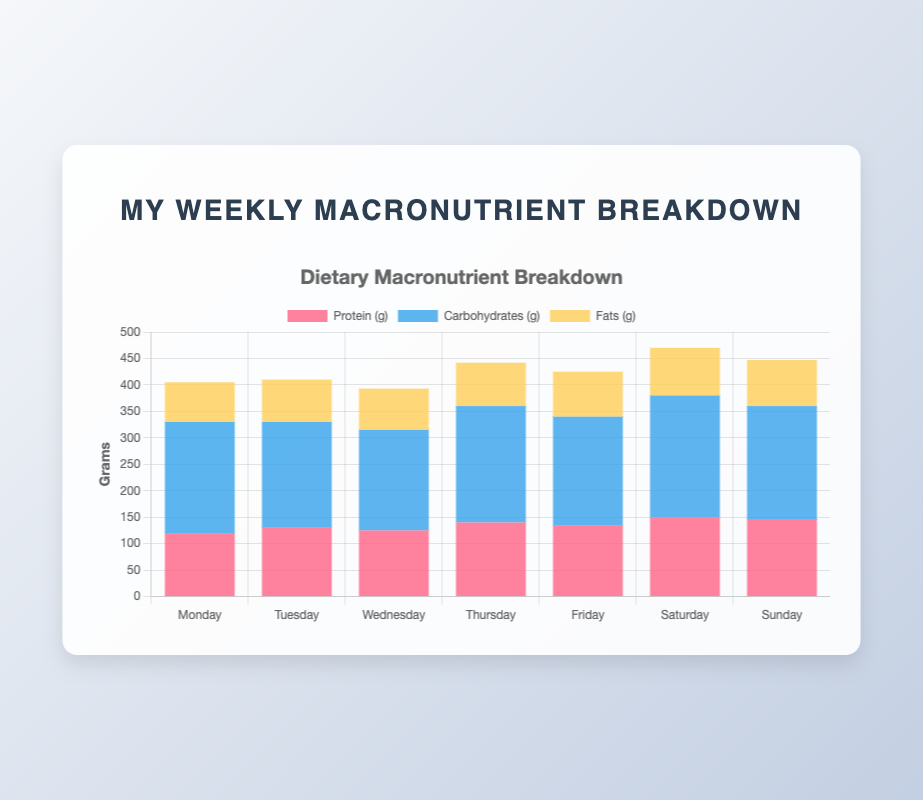What is the total amount of protein consumed over the week? Sum the protein intake for each day: 120 + 130 + 125 + 140 + 135 + 150 + 145 = 945 grams
Answer: 945 grams Which day did you consume the most carbohydrates? Compare the carbohydrate values for each day to find the maximum: Monday (210), Tuesday (200), Wednesday (190), Thursday (220), Friday (205), Saturday (230), Sunday (215). The highest value is on Saturday with 230 grams
Answer: Saturday What is the average fat intake per day? Sum the daily fat intake and divide by the number of days: (75 + 80 + 78 + 82 + 85 + 90 + 87) / 7 = 577 / 7 ≈ 82.43 grams
Answer: 82.43 grams How does the protein intake on Wednesday compare to Tuesday? Compare the protein intake on both days: Wednesday (125 grams) is less than Tuesday (130 grams)
Answer: Less than Tuesday Which macronutrient has the highest total intake for the week? Sum the intake for each macronutrient over the week: Protein (945 grams), Carbohydrates (1470 grams), Fats (577 grams). Carbohydrates have the highest total
Answer: Carbohydrates On which day is the summed carbohydrate and fat intake closest to 300 grams? Calculate the sum of carbohydrates and fats for each day and find the closest to 300 grams: Monday (285), Tuesday (280), Wednesday (268), Thursday (302), Friday (290), Saturday (320), Sunday (302). The closest is Thursday
Answer: Thursday What is the range of the fat intake over the week? Find the difference between the maximum and minimum fat values: Maximum (90 grams on Saturday), Minimum (75 grams on Monday). Range = 90 - 75 = 15 grams
Answer: 15 grams Is there any day where the protein intake exceeds 140 grams? Look for days with protein intake higher than 140 grams: Thursday (140 grams), Saturday (150 grams), Sunday (145 grams). Both Saturday and Sunday exceed 140 grams
Answer: Yes, Saturday and Sunday 